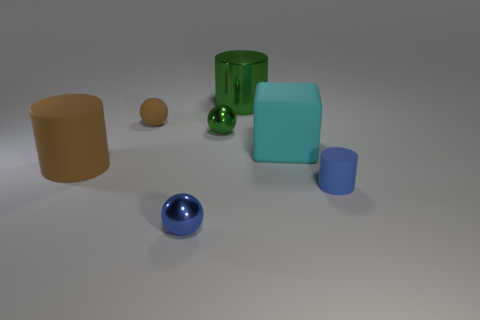Do the big matte block and the rubber object behind the cube have the same color? The big matte block and the rubber object behind the cube appear to be different shades. The block exhibits a more muted teal, whereas the rubber object has a deeper green hue. The differences in material properties like texture and finish can also affect color perception. 